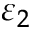Convert formula to latex. <formula><loc_0><loc_0><loc_500><loc_500>\varepsilon _ { 2 }</formula> 